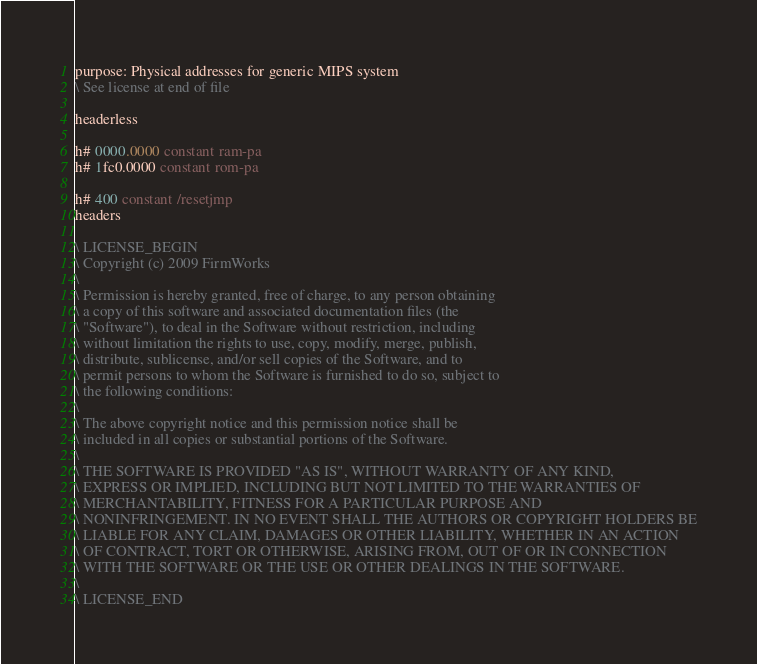Convert code to text. <code><loc_0><loc_0><loc_500><loc_500><_Forth_>purpose: Physical addresses for generic MIPS system
\ See license at end of file

headerless

h# 0000.0000 constant ram-pa
h# 1fc0.0000 constant rom-pa

h# 400 constant /resetjmp
headers

\ LICENSE_BEGIN
\ Copyright (c) 2009 FirmWorks
\ 
\ Permission is hereby granted, free of charge, to any person obtaining
\ a copy of this software and associated documentation files (the
\ "Software"), to deal in the Software without restriction, including
\ without limitation the rights to use, copy, modify, merge, publish,
\ distribute, sublicense, and/or sell copies of the Software, and to
\ permit persons to whom the Software is furnished to do so, subject to
\ the following conditions:
\ 
\ The above copyright notice and this permission notice shall be
\ included in all copies or substantial portions of the Software.
\ 
\ THE SOFTWARE IS PROVIDED "AS IS", WITHOUT WARRANTY OF ANY KIND,
\ EXPRESS OR IMPLIED, INCLUDING BUT NOT LIMITED TO THE WARRANTIES OF
\ MERCHANTABILITY, FITNESS FOR A PARTICULAR PURPOSE AND
\ NONINFRINGEMENT. IN NO EVENT SHALL THE AUTHORS OR COPYRIGHT HOLDERS BE
\ LIABLE FOR ANY CLAIM, DAMAGES OR OTHER LIABILITY, WHETHER IN AN ACTION
\ OF CONTRACT, TORT OR OTHERWISE, ARISING FROM, OUT OF OR IN CONNECTION
\ WITH THE SOFTWARE OR THE USE OR OTHER DEALINGS IN THE SOFTWARE.
\
\ LICENSE_END
</code> 